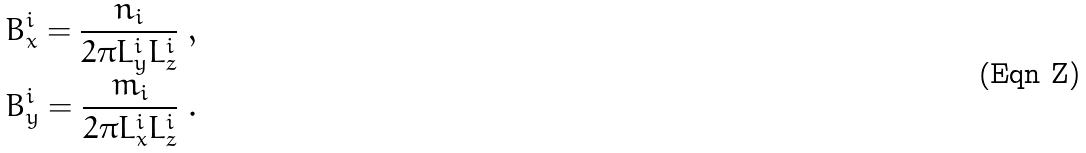Convert formula to latex. <formula><loc_0><loc_0><loc_500><loc_500>& B _ { x } ^ { i } = \frac { n _ { i } } { 2 \pi L _ { y } ^ { i } L _ { z } ^ { i } } \ , \\ & B _ { y } ^ { i } = \frac { m _ { i } } { 2 \pi L _ { x } ^ { i } L _ { z } ^ { i } } \ .</formula> 